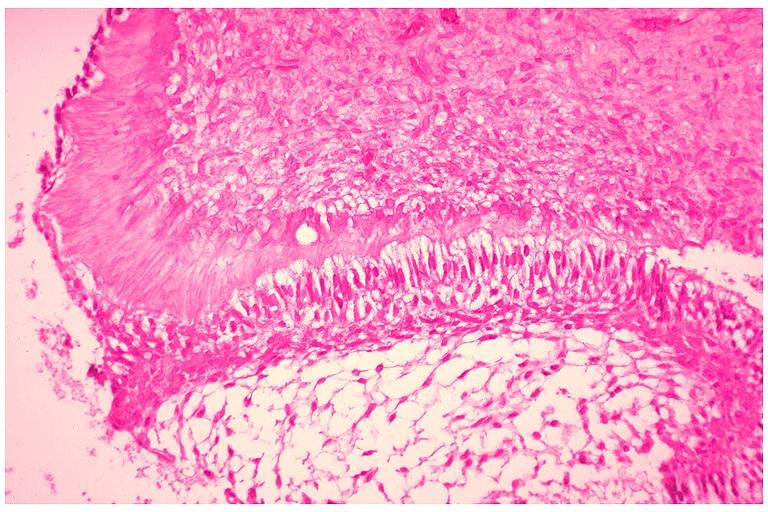what does this image show?
Answer the question using a single word or phrase. Developing 3rd molar 